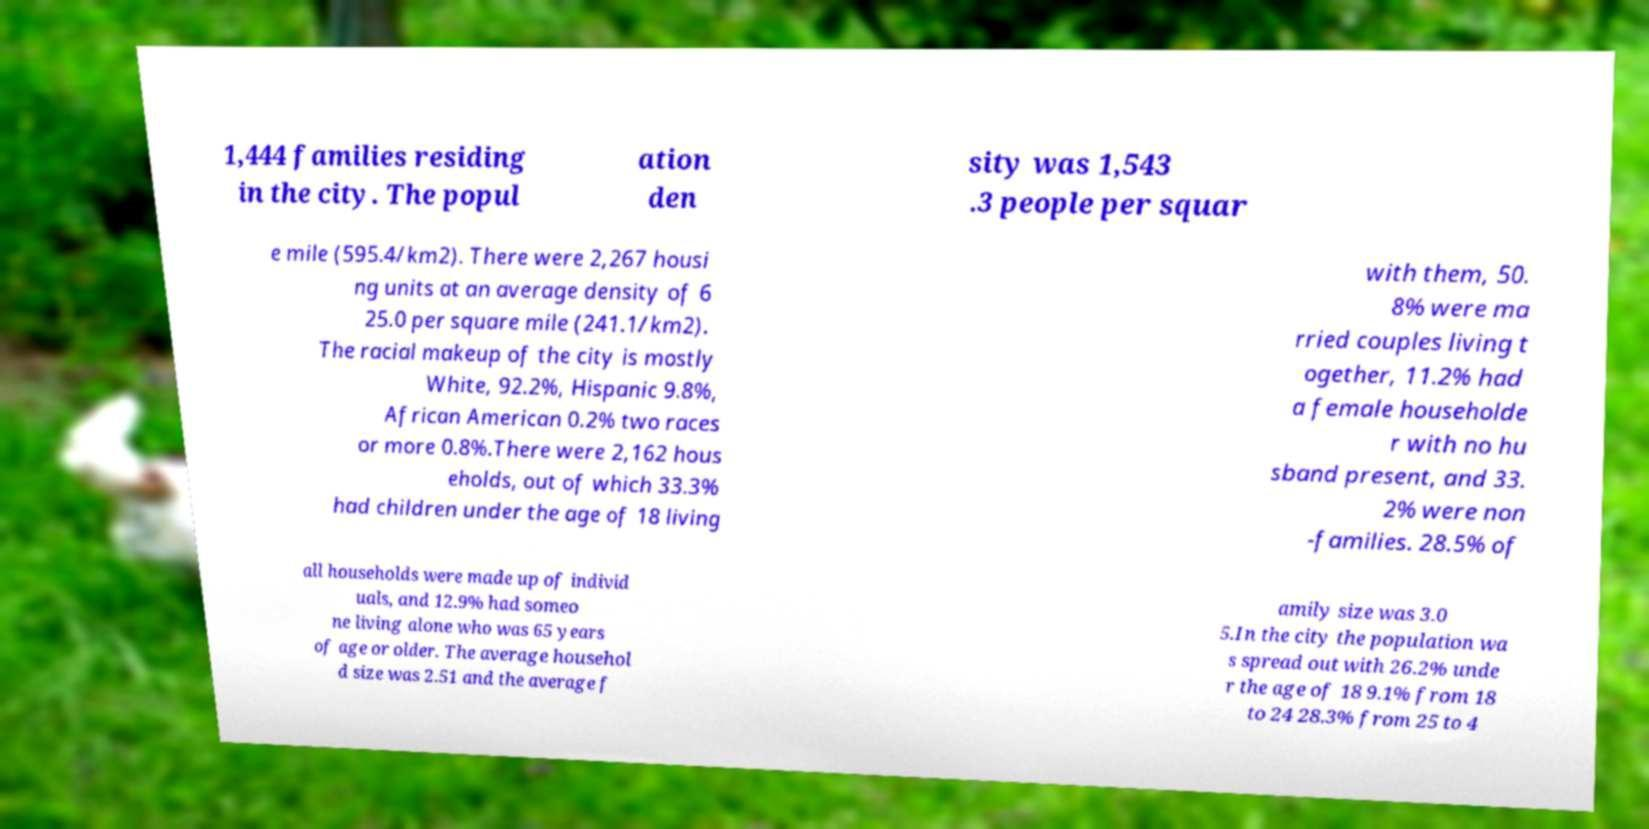Can you accurately transcribe the text from the provided image for me? 1,444 families residing in the city. The popul ation den sity was 1,543 .3 people per squar e mile (595.4/km2). There were 2,267 housi ng units at an average density of 6 25.0 per square mile (241.1/km2). The racial makeup of the city is mostly White, 92.2%, Hispanic 9.8%, African American 0.2% two races or more 0.8%.There were 2,162 hous eholds, out of which 33.3% had children under the age of 18 living with them, 50. 8% were ma rried couples living t ogether, 11.2% had a female householde r with no hu sband present, and 33. 2% were non -families. 28.5% of all households were made up of individ uals, and 12.9% had someo ne living alone who was 65 years of age or older. The average househol d size was 2.51 and the average f amily size was 3.0 5.In the city the population wa s spread out with 26.2% unde r the age of 18 9.1% from 18 to 24 28.3% from 25 to 4 